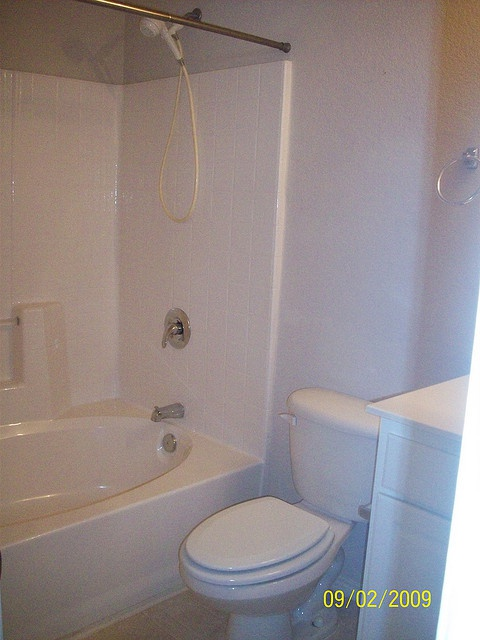Describe the objects in this image and their specific colors. I can see a toilet in maroon, darkgray, and gray tones in this image. 